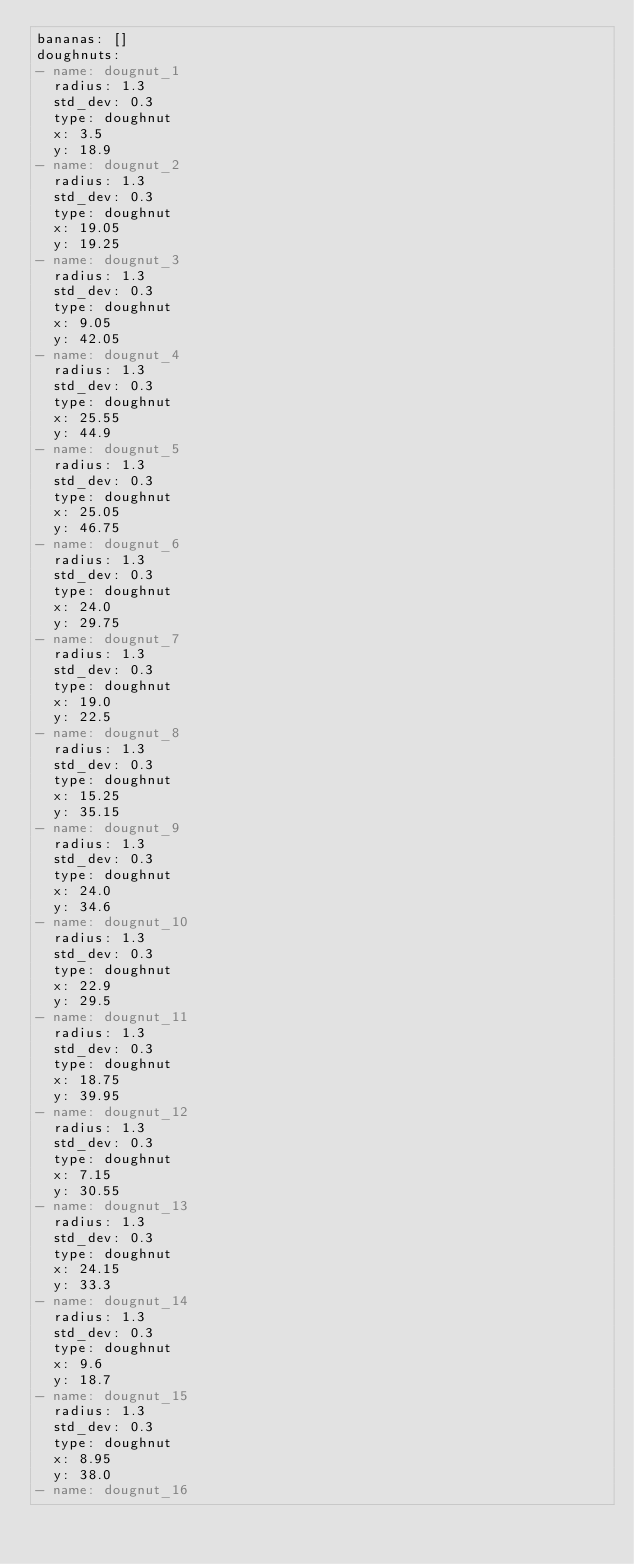<code> <loc_0><loc_0><loc_500><loc_500><_YAML_>bananas: []
doughnuts:
- name: dougnut_1
  radius: 1.3
  std_dev: 0.3
  type: doughnut
  x: 3.5
  y: 18.9
- name: dougnut_2
  radius: 1.3
  std_dev: 0.3
  type: doughnut
  x: 19.05
  y: 19.25
- name: dougnut_3
  radius: 1.3
  std_dev: 0.3
  type: doughnut
  x: 9.05
  y: 42.05
- name: dougnut_4
  radius: 1.3
  std_dev: 0.3
  type: doughnut
  x: 25.55
  y: 44.9
- name: dougnut_5
  radius: 1.3
  std_dev: 0.3
  type: doughnut
  x: 25.05
  y: 46.75
- name: dougnut_6
  radius: 1.3
  std_dev: 0.3
  type: doughnut
  x: 24.0
  y: 29.75
- name: dougnut_7
  radius: 1.3
  std_dev: 0.3
  type: doughnut
  x: 19.0
  y: 22.5
- name: dougnut_8
  radius: 1.3
  std_dev: 0.3
  type: doughnut
  x: 15.25
  y: 35.15
- name: dougnut_9
  radius: 1.3
  std_dev: 0.3
  type: doughnut
  x: 24.0
  y: 34.6
- name: dougnut_10
  radius: 1.3
  std_dev: 0.3
  type: doughnut
  x: 22.9
  y: 29.5
- name: dougnut_11
  radius: 1.3
  std_dev: 0.3
  type: doughnut
  x: 18.75
  y: 39.95
- name: dougnut_12
  radius: 1.3
  std_dev: 0.3
  type: doughnut
  x: 7.15
  y: 30.55
- name: dougnut_13
  radius: 1.3
  std_dev: 0.3
  type: doughnut
  x: 24.15
  y: 33.3
- name: dougnut_14
  radius: 1.3
  std_dev: 0.3
  type: doughnut
  x: 9.6
  y: 18.7
- name: dougnut_15
  radius: 1.3
  std_dev: 0.3
  type: doughnut
  x: 8.95
  y: 38.0
- name: dougnut_16</code> 